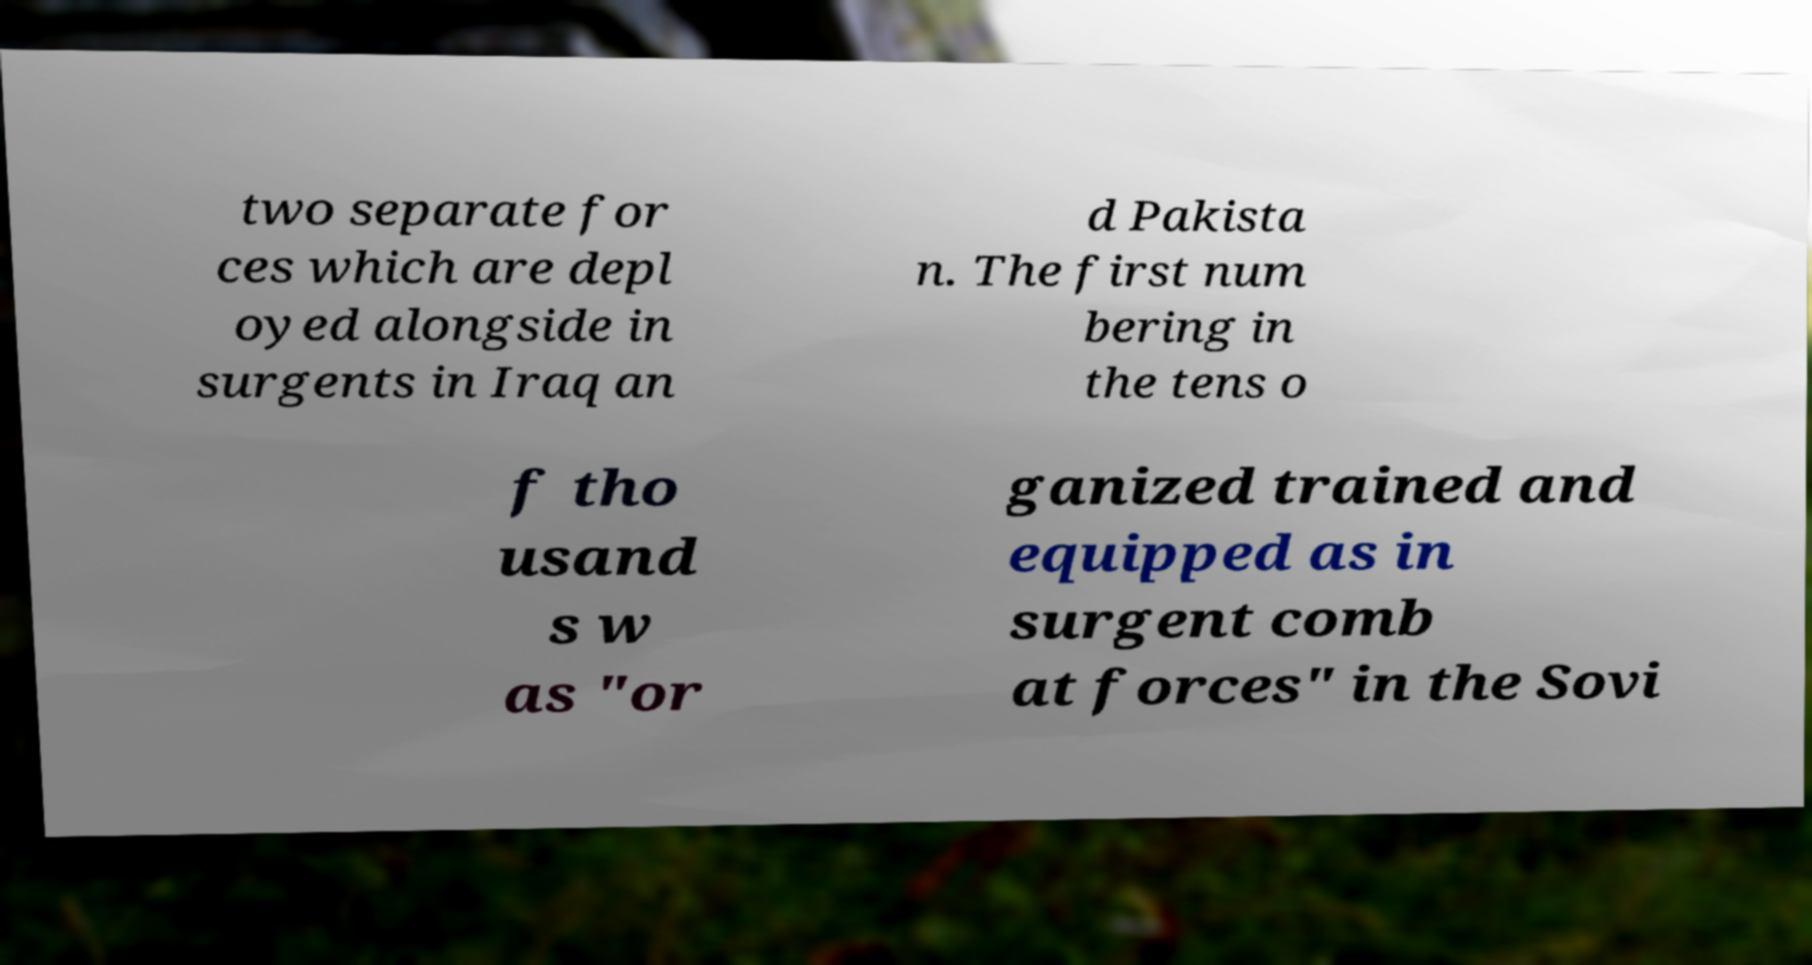Please read and relay the text visible in this image. What does it say? two separate for ces which are depl oyed alongside in surgents in Iraq an d Pakista n. The first num bering in the tens o f tho usand s w as "or ganized trained and equipped as in surgent comb at forces" in the Sovi 